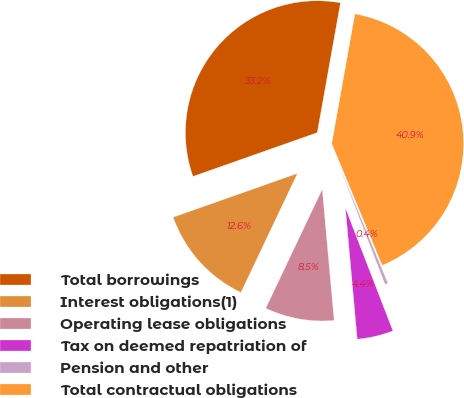Convert chart to OTSL. <chart><loc_0><loc_0><loc_500><loc_500><pie_chart><fcel>Total borrowings<fcel>Interest obligations(1)<fcel>Operating lease obligations<fcel>Tax on deemed repatriation of<fcel>Pension and other<fcel>Total contractual obligations<nl><fcel>33.21%<fcel>12.55%<fcel>8.49%<fcel>4.44%<fcel>0.38%<fcel>40.93%<nl></chart> 